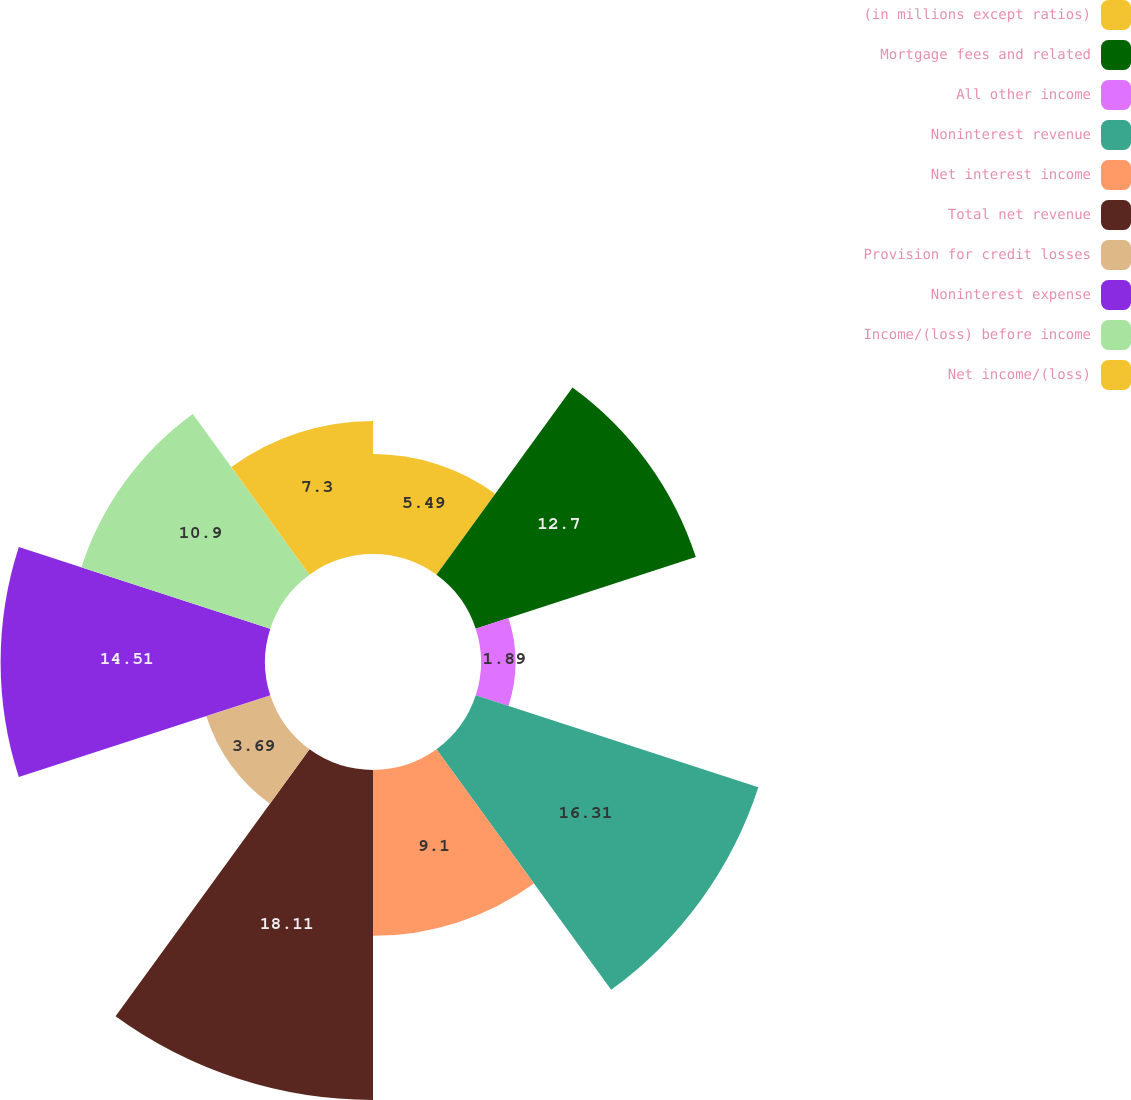Convert chart. <chart><loc_0><loc_0><loc_500><loc_500><pie_chart><fcel>(in millions except ratios)<fcel>Mortgage fees and related<fcel>All other income<fcel>Noninterest revenue<fcel>Net interest income<fcel>Total net revenue<fcel>Provision for credit losses<fcel>Noninterest expense<fcel>Income/(loss) before income<fcel>Net income/(loss)<nl><fcel>5.49%<fcel>12.7%<fcel>1.89%<fcel>16.31%<fcel>9.1%<fcel>18.11%<fcel>3.69%<fcel>14.51%<fcel>10.9%<fcel>7.3%<nl></chart> 